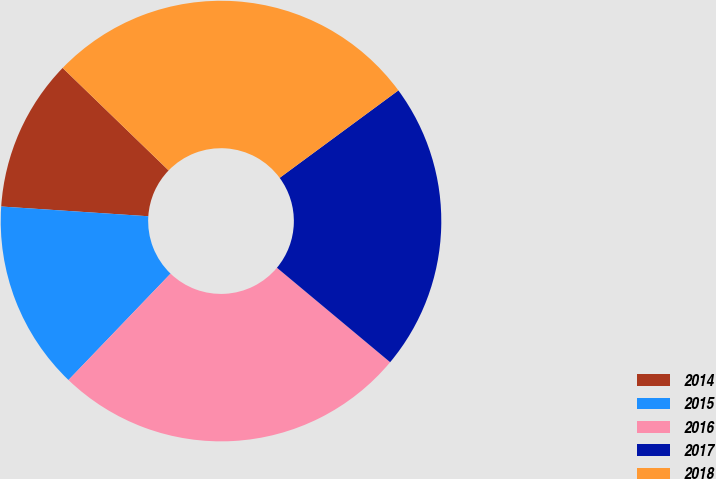Convert chart to OTSL. <chart><loc_0><loc_0><loc_500><loc_500><pie_chart><fcel>2014<fcel>2015<fcel>2016<fcel>2017<fcel>2018<nl><fcel>11.18%<fcel>13.88%<fcel>26.1%<fcel>21.17%<fcel>27.66%<nl></chart> 